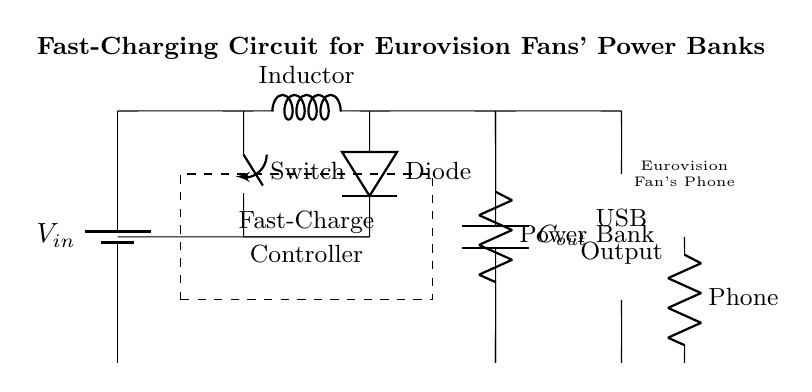What is the main role of the inductor in this circuit? The inductor is used to store energy in a magnetic field and helps in converting the input voltage to a lower output voltage through the buck converter action in this circuit.
Answer: Energy storage What component creates a one-way current flow in this circuit? The diode is responsible for allowing current to flow in only one direction, preventing backflow and protecting the circuit components from potential damage.
Answer: Diode What is the purpose of the fast-charge controller? The fast-charge controller regulates the charging process of the power bank, ensuring that the device is charged quickly and efficiently while managing the output current and voltage levels.
Answer: Regulation of charging How many outputs does the circuit provide? The circuit provides one output, specifically designed for USB connections to charge mobile devices such as phones during events like Eurovision watch parties.
Answer: One output What is the stored charge component in the circuit? The capacitor (Cout) serves as the component that stores electrical charge, smoothing out the voltage output and ensuring stable power delivery to the connected devices.
Answer: Capacitor What type of load is represented in this circuit? The power bank is the load in this circuit, serving as an energy storage device that supplies power to the mobile devices during use.
Answer: Power bank 